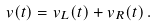<formula> <loc_0><loc_0><loc_500><loc_500>v ( t ) = v _ { L } ( t ) + v _ { R } ( t ) \, .</formula> 